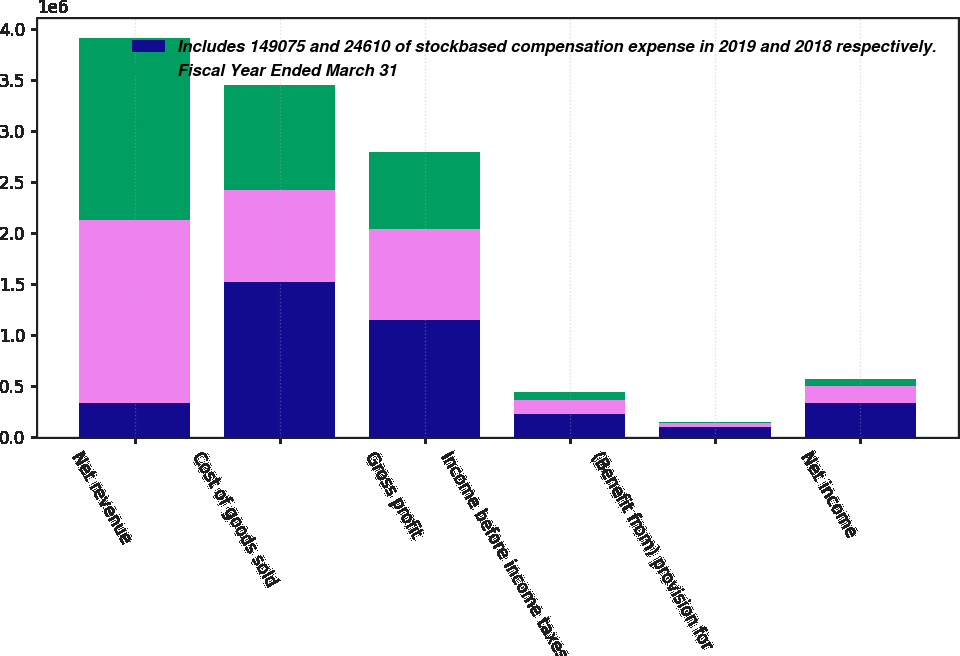Convert chart to OTSL. <chart><loc_0><loc_0><loc_500><loc_500><stacked_bar_chart><ecel><fcel>Net revenue<fcel>Cost of goods sold<fcel>Gross profit<fcel>Income before income taxes<fcel>(Benefit from) provision for<fcel>Net income<nl><fcel>Includes 149075 and 24610 of stockbased compensation expense in 2019 and 2018 respectively.<fcel>333837<fcel>1.52364e+06<fcel>1.14475e+06<fcel>232785<fcel>101052<fcel>333837<nl><fcel>nan<fcel>1.79289e+06<fcel>898311<fcel>894581<fcel>136625<fcel>36908<fcel>173533<nl><fcel>Fiscal Year Ended March 31<fcel>1.77975e+06<fcel>1.02296e+06<fcel>756789<fcel>76965<fcel>9662<fcel>67303<nl></chart> 